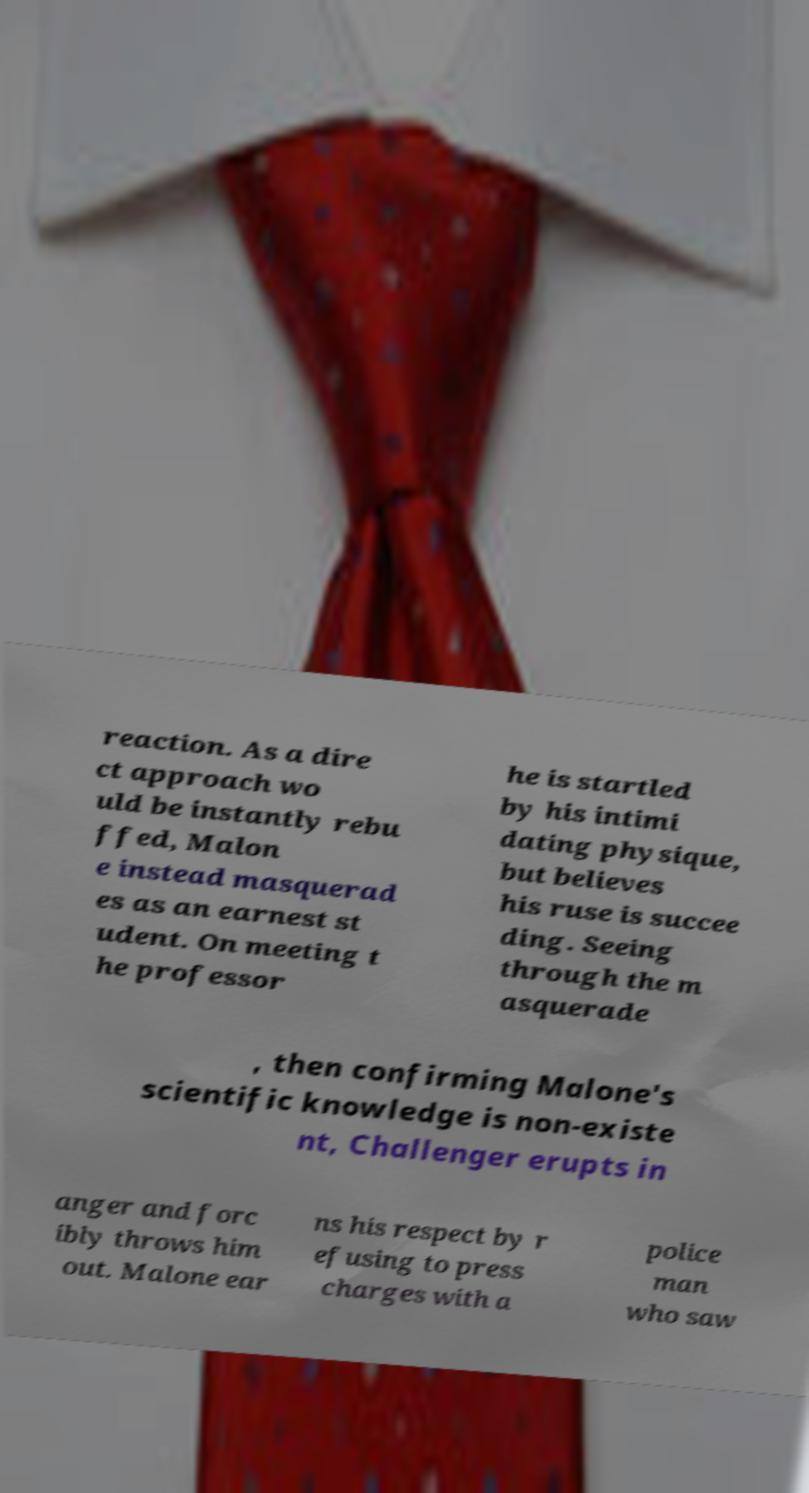Please read and relay the text visible in this image. What does it say? reaction. As a dire ct approach wo uld be instantly rebu ffed, Malon e instead masquerad es as an earnest st udent. On meeting t he professor he is startled by his intimi dating physique, but believes his ruse is succee ding. Seeing through the m asquerade , then confirming Malone's scientific knowledge is non-existe nt, Challenger erupts in anger and forc ibly throws him out. Malone ear ns his respect by r efusing to press charges with a police man who saw 